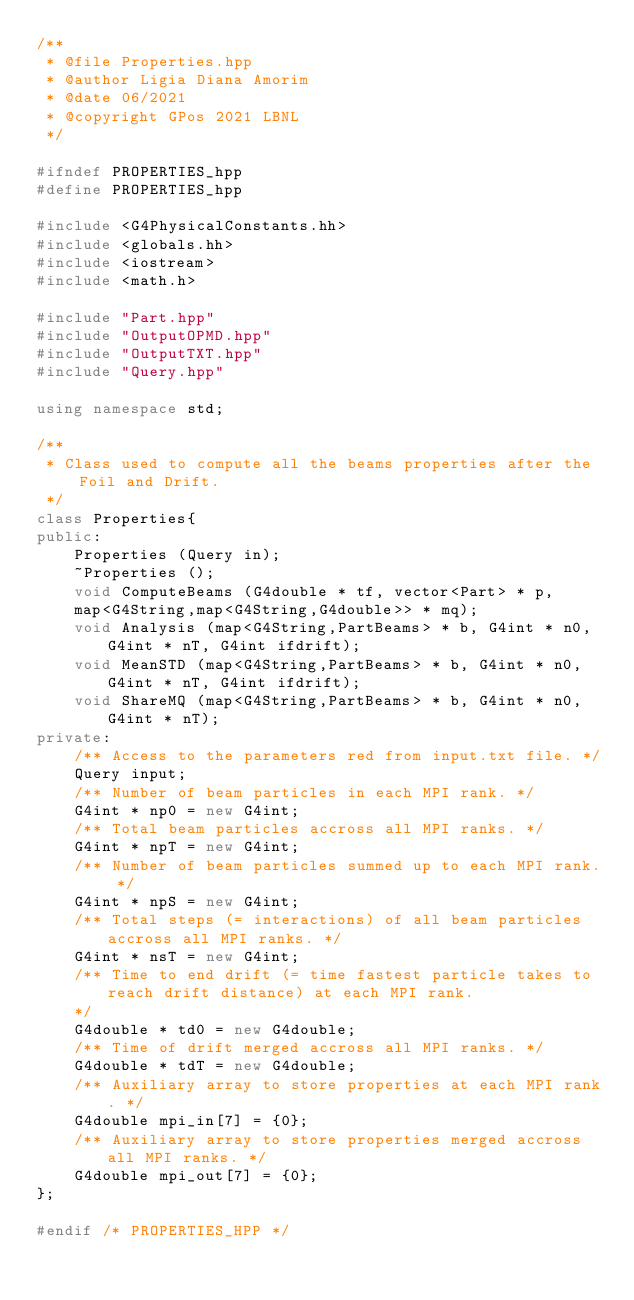Convert code to text. <code><loc_0><loc_0><loc_500><loc_500><_C++_>/**
 * @file Properties.hpp
 * @author Ligia Diana Amorim
 * @date 06/2021
 * @copyright GPos 2021 LBNL
 */

#ifndef PROPERTIES_hpp
#define PROPERTIES_hpp

#include <G4PhysicalConstants.hh>
#include <globals.hh>
#include <iostream>
#include <math.h>

#include "Part.hpp"
#include "OutputOPMD.hpp"
#include "OutputTXT.hpp"
#include "Query.hpp"

using namespace std;

/**
 * Class used to compute all the beams properties after the Foil and Drift.
 */
class Properties{
public:
    Properties (Query in);
    ~Properties ();
    void ComputeBeams (G4double * tf, vector<Part> * p,
    map<G4String,map<G4String,G4double>> * mq);
    void Analysis (map<G4String,PartBeams> * b, G4int * n0, G4int * nT, G4int ifdrift);
    void MeanSTD (map<G4String,PartBeams> * b, G4int * n0, G4int * nT, G4int ifdrift);
    void ShareMQ (map<G4String,PartBeams> * b, G4int * n0, G4int * nT);
private:
    /** Access to the parameters red from input.txt file. */
    Query input;
    /** Number of beam particles in each MPI rank. */
    G4int * np0 = new G4int;
    /** Total beam particles accross all MPI ranks. */
    G4int * npT = new G4int;
    /** Number of beam particles summed up to each MPI rank. */
    G4int * npS = new G4int;
    /** Total steps (= interactions) of all beam particles accross all MPI ranks. */
    G4int * nsT = new G4int;
    /** Time to end drift (= time fastest particle takes to reach drift distance) at each MPI rank. 
    */
    G4double * td0 = new G4double;
    /** Time of drift merged accross all MPI ranks. */
    G4double * tdT = new G4double;
    /** Auxiliary array to store properties at each MPI rank. */
    G4double mpi_in[7] = {0};
    /** Auxiliary array to store properties merged accross all MPI ranks. */
    G4double mpi_out[7] = {0};
};

#endif /* PROPERTIES_HPP */</code> 